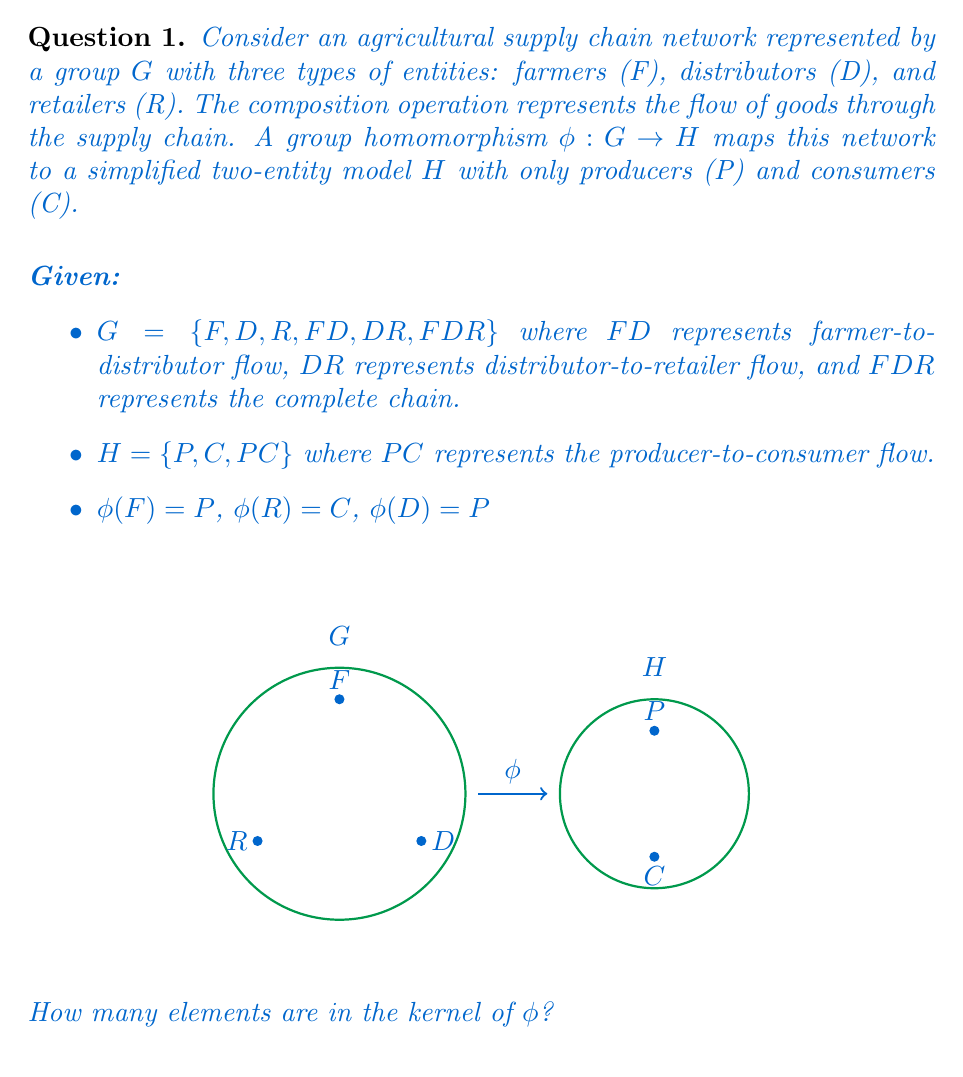Solve this math problem. To find the kernel of the group homomorphism $\phi$, we need to determine which elements of $G$ map to the identity element in $H$. Let's follow these steps:

1) First, identify the identity element in $H$:
   The identity in $H$ is $P$ (producer), as $P * P = P$, $P * C = C$, and $P * PC = PC$.

2) Now, let's map each element of $G$ using $\phi$:
   
   $\phi(F) = P$
   $\phi(D) = P$
   $\phi(R) = C$
   $\phi(FD) = \phi(F) * \phi(D) = P * P = P$
   $\phi(DR) = \phi(D) * \phi(R) = P * C = C$
   $\phi(FDR) = \phi(F) * \phi(D) * \phi(R) = P * P * C = C$

3) The kernel of $\phi$ consists of all elements in $G$ that map to $P$ in $H$:

   $ker(\phi) = \{x \in G | \phi(x) = P\}$

4) From our mappings, we can see that $F$, $D$, and $FD$ all map to $P$.

5) Therefore, the kernel of $\phi$ is $\{F, D, FD\}$.

6) Count the elements in the kernel: there are 3 elements.
Answer: 3 